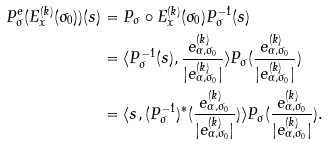Convert formula to latex. <formula><loc_0><loc_0><loc_500><loc_500>P ^ { e } _ { \sigma } ( E ^ { ( k ) } _ { x } ( \sigma _ { 0 } ) ) ( s ) & = P _ { \sigma } \circ E ^ { ( k ) } _ { x } ( \sigma _ { 0 } ) P _ { \sigma } ^ { - 1 } ( s ) \\ & = \langle P _ { \sigma } ^ { - 1 } ( s ) , \frac { e _ { \alpha , \sigma _ { 0 } } ^ { ( k ) } } { | e _ { \alpha , \sigma _ { 0 } } ^ { ( k ) } | } \rangle P _ { \sigma } ( \frac { e _ { \alpha , \sigma _ { 0 } } ^ { ( k ) } } { | e _ { \alpha , \sigma _ { 0 } } ^ { ( k ) } | } ) \\ & = \langle s , ( P _ { \sigma } ^ { - 1 } ) ^ { * } ( \frac { e _ { \alpha , \sigma _ { 0 } } ^ { ( k ) } } { | e _ { \alpha , \sigma _ { 0 } } ^ { ( k ) } | } ) \rangle P _ { \sigma } ( \frac { e _ { \alpha , \sigma _ { 0 } } ^ { ( k ) } } { | e _ { \alpha , \sigma _ { 0 } } ^ { ( k ) } | } ) .</formula> 